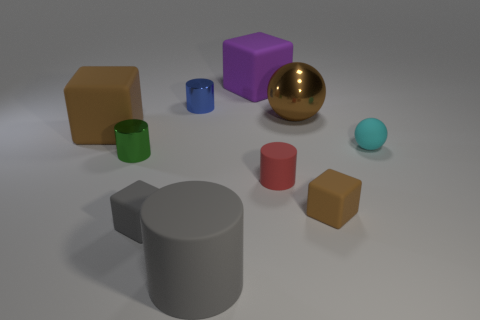Subtract all brown cylinders. How many brown blocks are left? 2 Subtract 1 cylinders. How many cylinders are left? 3 Subtract all gray blocks. How many blocks are left? 3 Subtract all gray blocks. How many blocks are left? 3 Subtract all blocks. How many objects are left? 6 Add 2 big brown things. How many big brown things are left? 4 Add 3 tiny shiny things. How many tiny shiny things exist? 5 Subtract 1 cyan spheres. How many objects are left? 9 Subtract all gray blocks. Subtract all gray cylinders. How many blocks are left? 3 Subtract all large gray things. Subtract all purple matte objects. How many objects are left? 8 